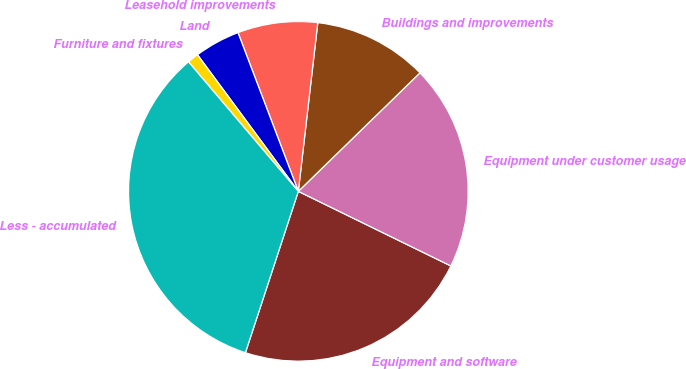Convert chart. <chart><loc_0><loc_0><loc_500><loc_500><pie_chart><fcel>Equipment and software<fcel>Equipment under customer usage<fcel>Buildings and improvements<fcel>Leasehold improvements<fcel>Land<fcel>Furniture and fixtures<fcel>Less - accumulated<nl><fcel>22.8%<fcel>19.53%<fcel>10.88%<fcel>7.61%<fcel>4.34%<fcel>1.07%<fcel>33.76%<nl></chart> 